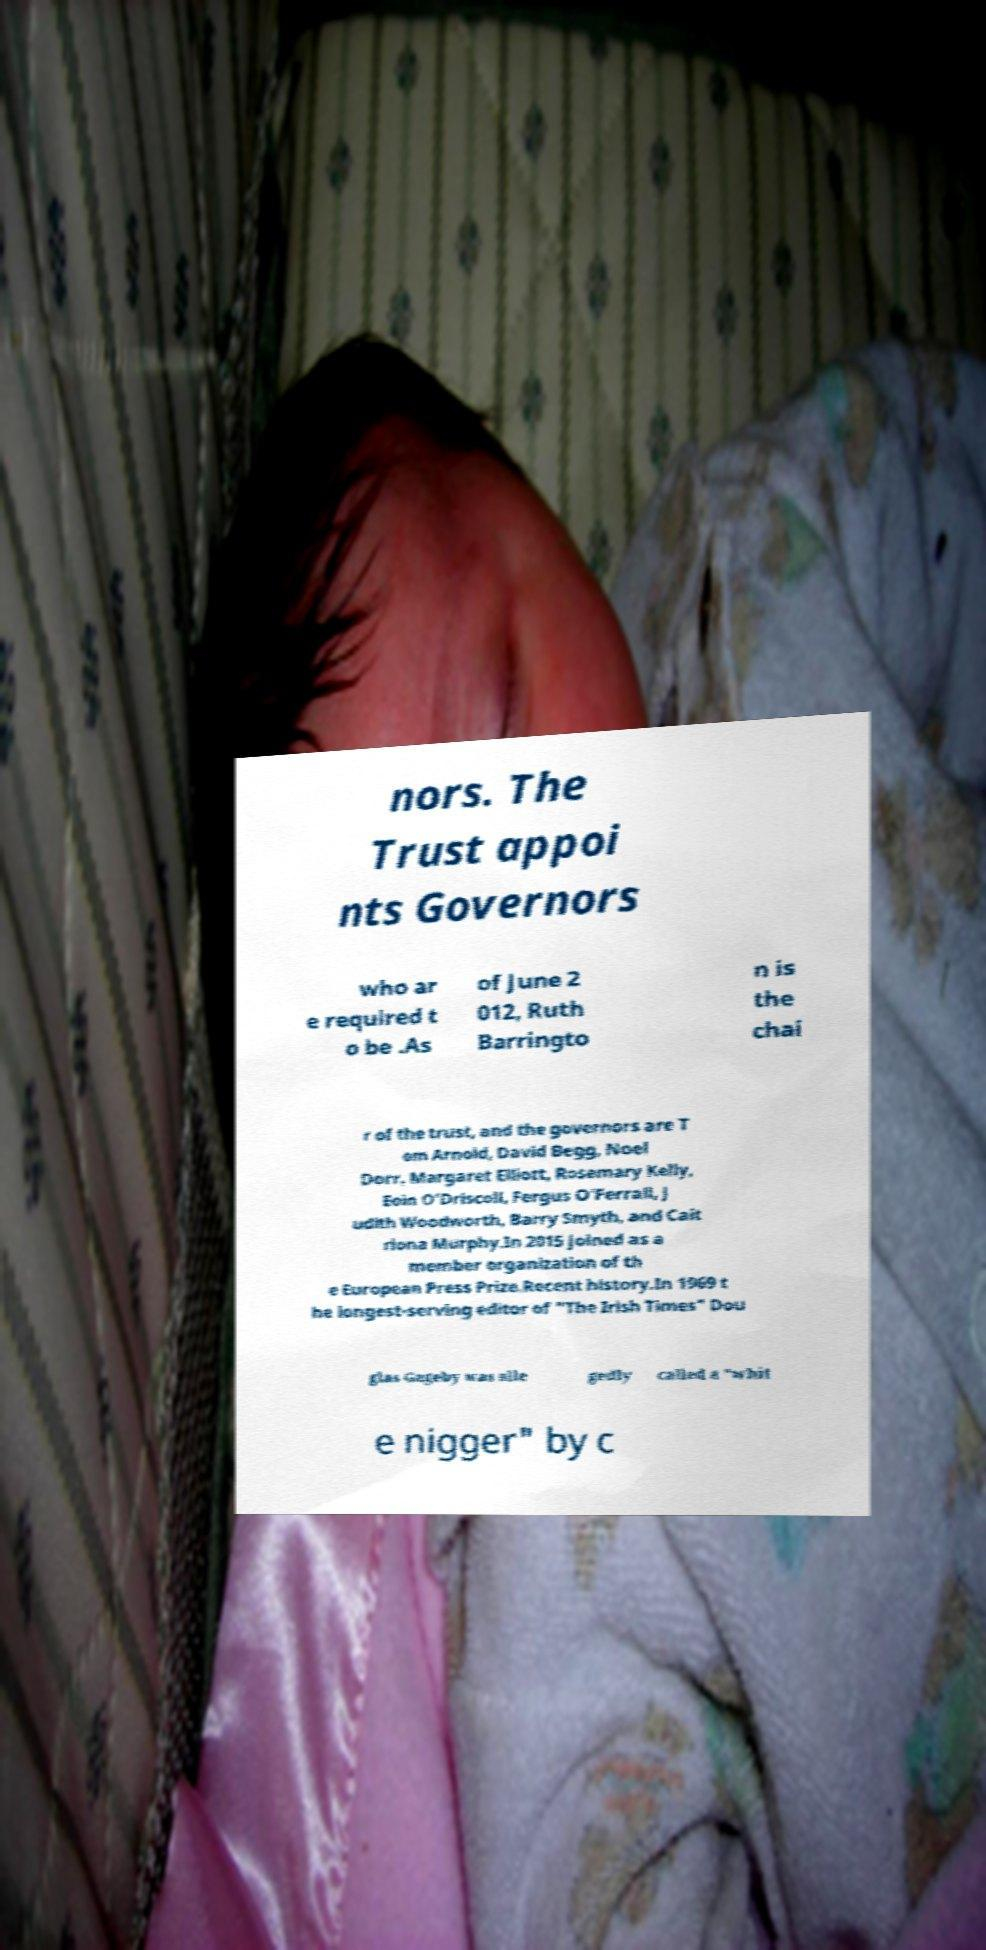Can you accurately transcribe the text from the provided image for me? nors. The Trust appoi nts Governors who ar e required t o be .As of June 2 012, Ruth Barringto n is the chai r of the trust, and the governors are T om Arnold, David Begg, Noel Dorr, Margaret Elliott, Rosemary Kelly, Eoin O'Driscoll, Fergus O'Ferrall, J udith Woodworth, Barry Smyth, and Cait riona Murphy.In 2015 joined as a member organization of th e European Press Prize.Recent history.In 1969 t he longest-serving editor of "The Irish Times" Dou glas Gageby was alle gedly called a "whit e nigger" by c 